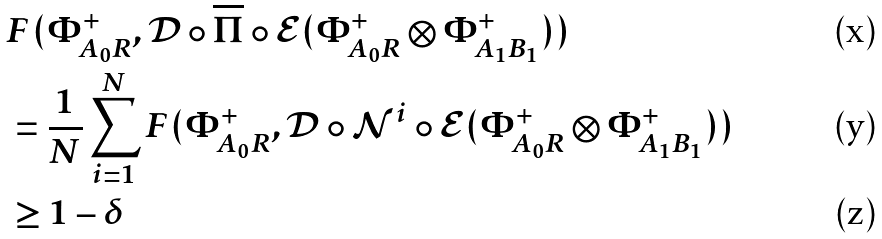Convert formula to latex. <formula><loc_0><loc_0><loc_500><loc_500>& F ( \Phi ^ { + } _ { A _ { 0 } R } , \mathcal { D } \circ \overline { \Pi } \circ \mathcal { E } ( \Phi ^ { + } _ { A _ { 0 } R } \otimes \Phi ^ { + } _ { A _ { 1 } B _ { 1 } } ) ) \\ & = \frac { 1 } { N } \sum _ { i = 1 } ^ { N } F ( \Phi ^ { + } _ { A _ { 0 } R } , \mathcal { D } \circ \mathcal { N } ^ { i } \circ \mathcal { E } ( \Phi ^ { + } _ { A _ { 0 } R } \otimes \Phi ^ { + } _ { A _ { 1 } B _ { 1 } } ) ) \\ & \geq 1 - \delta</formula> 